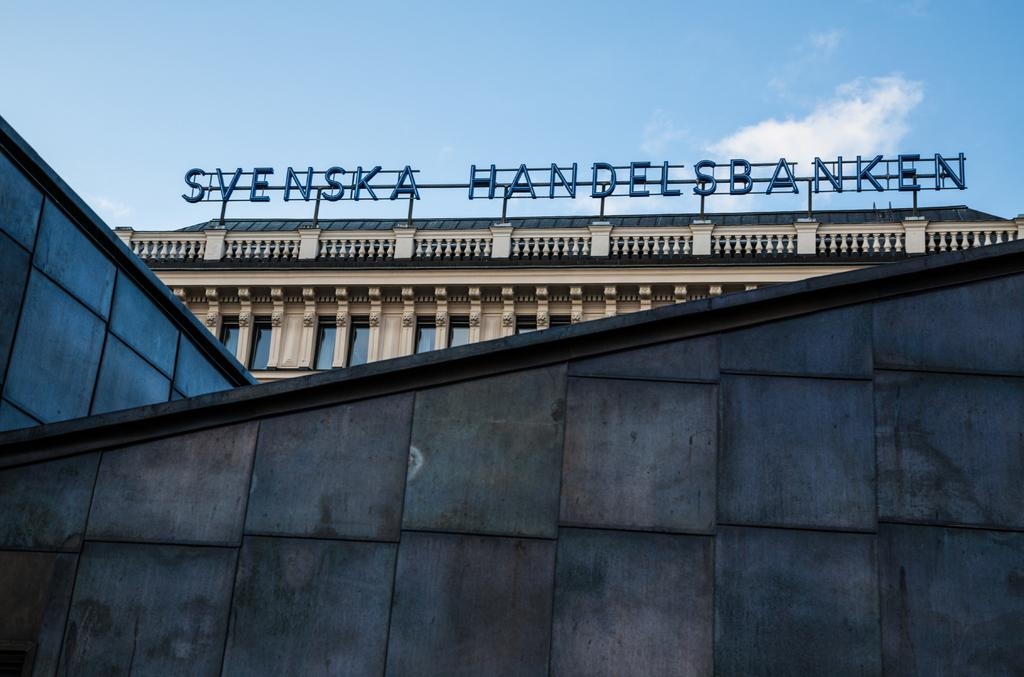What type of structures can be seen in the image? There are buildings in the image. Are there any specific details on the buildings? Yes, there are names on the buildings. What can be seen in the background of the image? The sky is visible in the background of the image. What type of barrier is present in the image? There is a wall in the image. What type of treatment is being administered to the mine in the image? There is no mine present in the image, and therefore no treatment can be administered to it. 